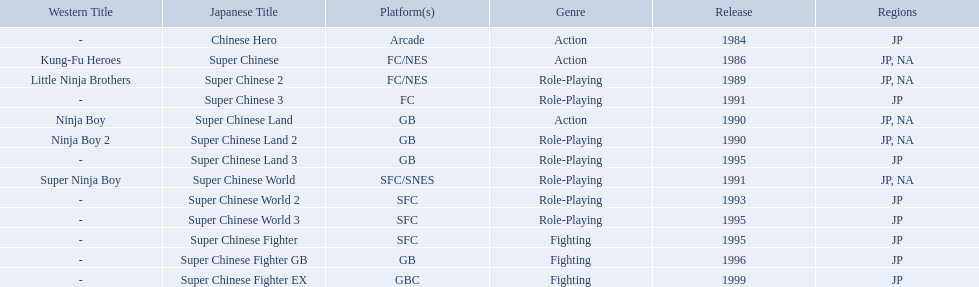Super ninja world was released in what countries? JP, NA. What was the original name for this title? Super Chinese World. 